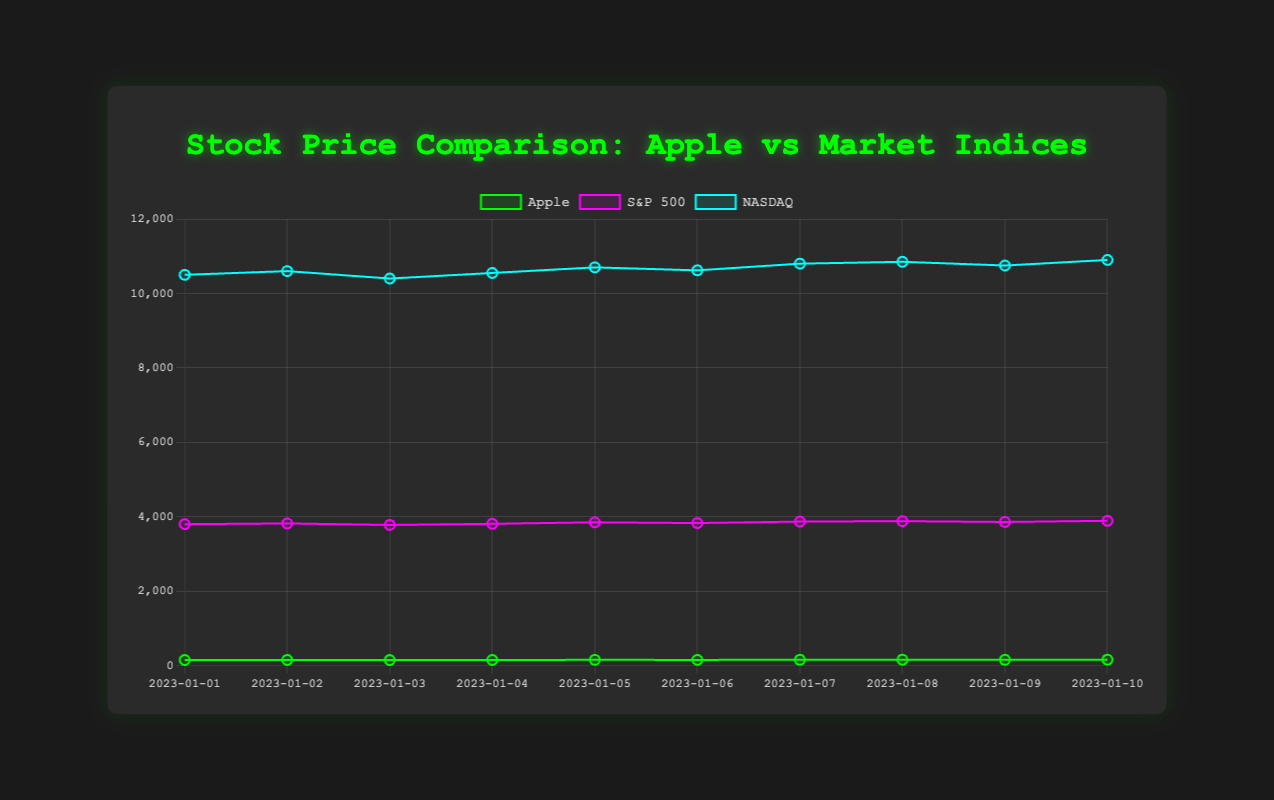What is the highest stock price of Apple in the given period? From the chart, the highest stock price of Apple can be identified by finding the peak point in the line plot for Apple. The highest point on the green line (representing Apple) is on 2023-01-10 with a stock price of 159.00.
Answer: 159.00 On what date did Apple’s stock price experience the largest single-day increase? To find the largest single-day increase, calculate the differences in stock price between consecutive days. Comparing these differences, the largest increase of 4 occurred between 2023-01-04 (151) and 2023-01-05 (155).
Answer: 2023-01-05 How did the NASDAQ perform relative to S&P 500 on the last day in the data period? On the last date, refer to where NASDAQ and S&P 500 lines are plotted. NASDAQ (blue) is higher (~10900) than S&P 500 (magenta) (~3890).
Answer: NASDAQ performed better What is the average stock price of Apple over the 10 days? To find this, sum Apple’s stock prices and then divide by the number of days: (150 + 152 + 148 + 151 + 155 + 153 + 157 + 158 + 156 + 159) / 10 = 1539 / 10 = 153.9.
Answer: 153.9 Which index increased the most from 2023-01-01 to 2023-01-10? Calculate the differences between the first and last datapoints for each index: S&P 500: 3890 - 3800 = 90, NASDAQ: 10900 - 10500 = 400. NASDAQ shows the largest increase of 400.
Answer: NASDAQ On which day did all three lines (Apple, S&P 500, and NASDAQ) peak together? Look for the date when all lines exhibit local maxima. No single date has all three lines at their peaks together; Apple's maximum is different from the others.
Answer: None What color represents S&P 500 in the chart? Visually identify the color used for the S&P 500 line. The S&P 500 line is colored in magenta (purple).
Answer: Magenta Which day did Apple’s stock price cross 150 for the first time in the period? Verify the dates when Apple’s stock price reaches or exceeds 150. The first occurrence is on 2023-01-01 with a stock price of 150.
Answer: 2023-01-01 What is the combined average value of the S&P 500 and NASDAQ on 2023-01-03? Add S&P 500 and NASDAQ values for 2023-01-03 and find the average: (3780 + 10400) / 2 = 7070.
Answer: 7070 How much did Apple’s stock price change from the start to the end of the period? Subtract Apple’s stock price on 2023-01-01 from the price on 2023-01-10: 159 - 150 = 9.
Answer: 9 